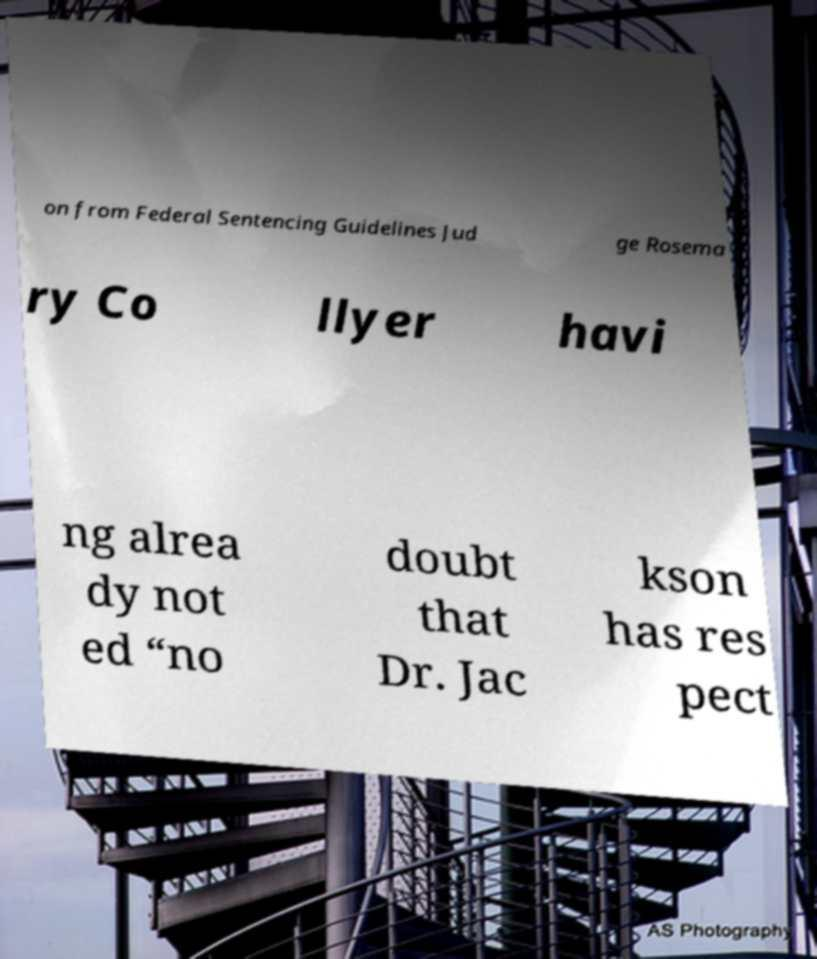Please identify and transcribe the text found in this image. on from Federal Sentencing Guidelines Jud ge Rosema ry Co llyer havi ng alrea dy not ed “no doubt that Dr. Jac kson has res pect 